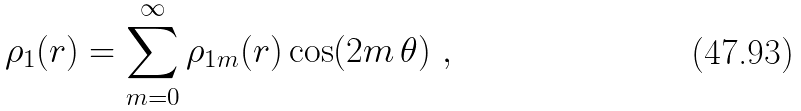<formula> <loc_0><loc_0><loc_500><loc_500>\rho _ { 1 } ( { r } ) = \sum _ { m = 0 } ^ { \infty } \rho _ { 1 m } ( r ) \cos ( 2 m \, \theta ) \ ,</formula> 